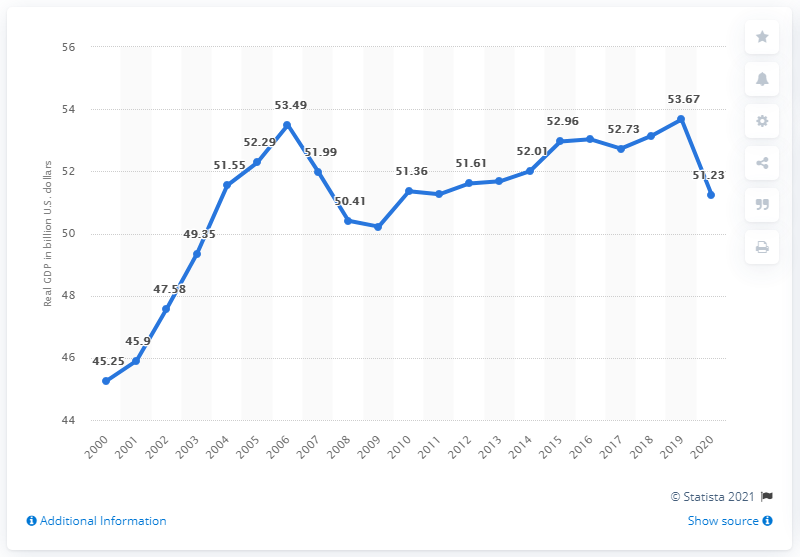Outline some significant characteristics in this image. In 2020, the Gross Domestic Product (GDP) of Rhode Island was 51.23 billion dollars. In the previous year, the Gross Domestic Product (GDP) of Rhode Island was approximately $53.67 billion. 